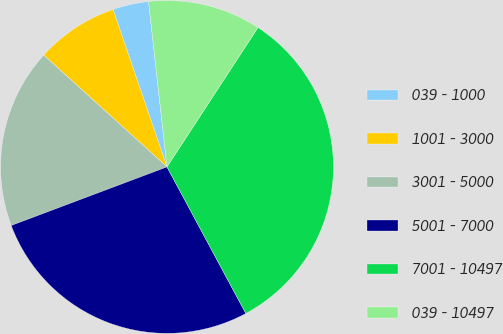<chart> <loc_0><loc_0><loc_500><loc_500><pie_chart><fcel>039 - 1000<fcel>1001 - 3000<fcel>3001 - 5000<fcel>5001 - 7000<fcel>7001 - 10497<fcel>039 - 10497<nl><fcel>3.49%<fcel>8.02%<fcel>17.45%<fcel>27.13%<fcel>32.94%<fcel>10.97%<nl></chart> 